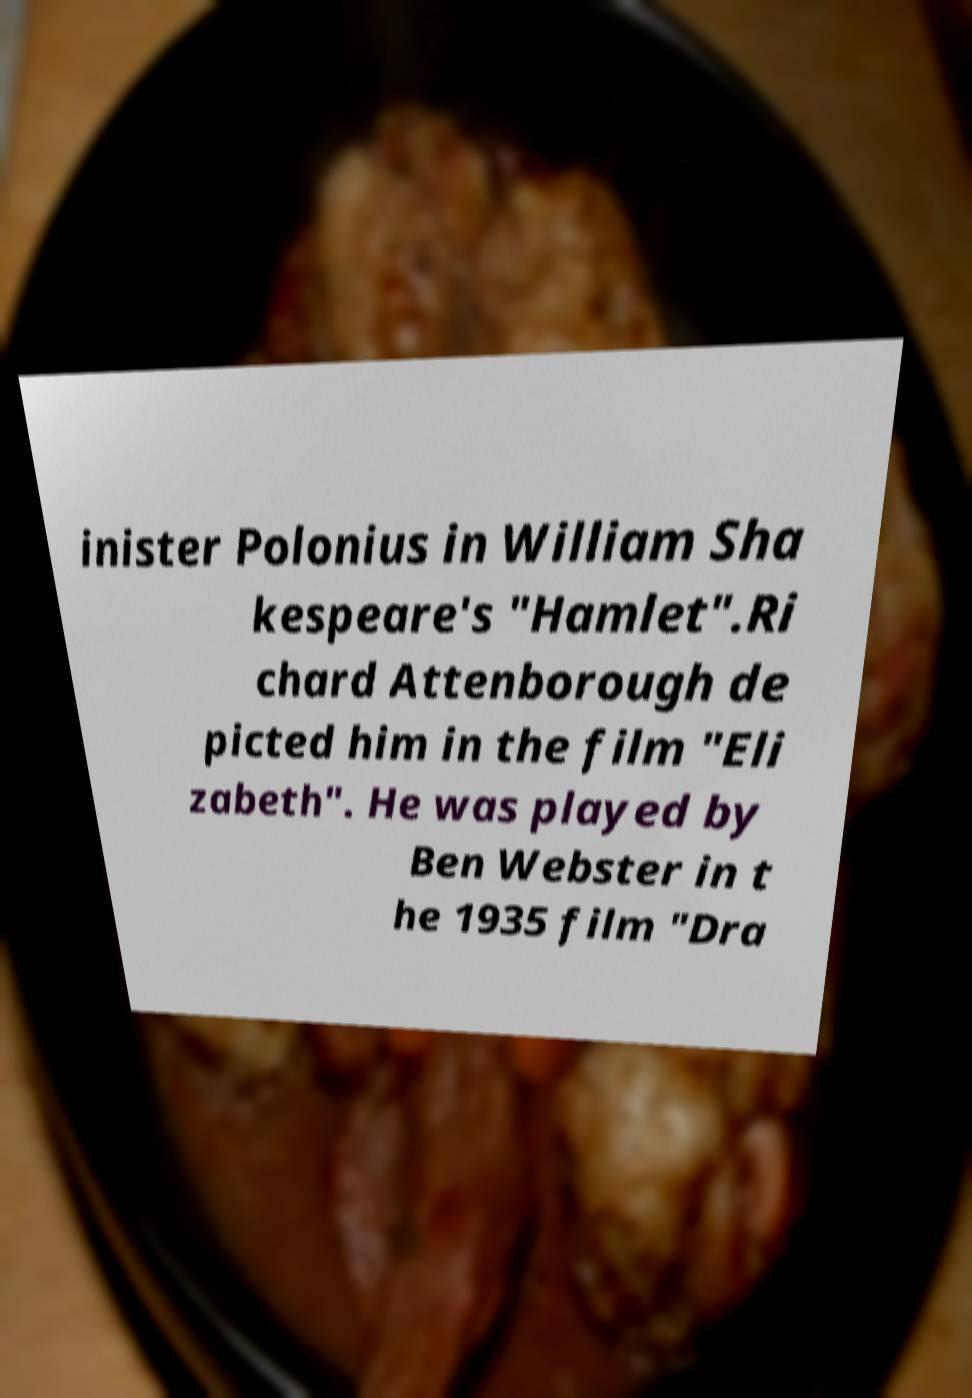Could you extract and type out the text from this image? inister Polonius in William Sha kespeare's "Hamlet".Ri chard Attenborough de picted him in the film "Eli zabeth". He was played by Ben Webster in t he 1935 film "Dra 